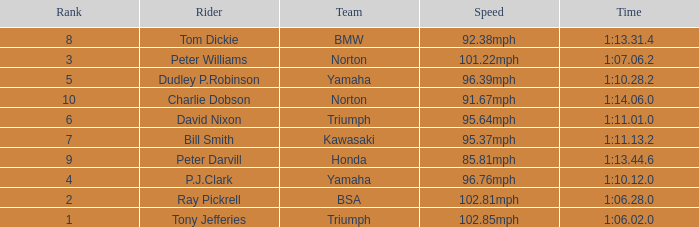How many Ranks have ray pickrell as a Rider? 1.0. Can you parse all the data within this table? {'header': ['Rank', 'Rider', 'Team', 'Speed', 'Time'], 'rows': [['8', 'Tom Dickie', 'BMW', '92.38mph', '1:13.31.4'], ['3', 'Peter Williams', 'Norton', '101.22mph', '1:07.06.2'], ['5', 'Dudley P.Robinson', 'Yamaha', '96.39mph', '1:10.28.2'], ['10', 'Charlie Dobson', 'Norton', '91.67mph', '1:14.06.0'], ['6', 'David Nixon', 'Triumph', '95.64mph', '1:11.01.0'], ['7', 'Bill Smith', 'Kawasaki', '95.37mph', '1:11.13.2'], ['9', 'Peter Darvill', 'Honda', '85.81mph', '1:13.44.6'], ['4', 'P.J.Clark', 'Yamaha', '96.76mph', '1:10.12.0'], ['2', 'Ray Pickrell', 'BSA', '102.81mph', '1:06.28.0'], ['1', 'Tony Jefferies', 'Triumph', '102.85mph', '1:06.02.0']]} 